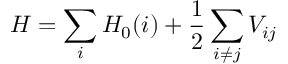<formula> <loc_0><loc_0><loc_500><loc_500>H = \sum _ { i } H _ { 0 } ( i ) + \frac { 1 } { 2 } \sum _ { i \neq j } V _ { i j }</formula> 